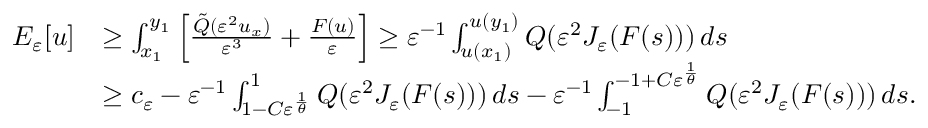<formula> <loc_0><loc_0><loc_500><loc_500>\begin{array} { r l } { E _ { \varepsilon } [ u ] } & { \geq \int _ { x _ { 1 } } ^ { y _ { 1 } } \left [ \frac { \tilde { Q } ( \varepsilon ^ { 2 } u _ { x } ) } { \varepsilon ^ { 3 } } + \frac { F ( u ) } { \varepsilon } \right ] \geq \varepsilon ^ { - 1 } \int _ { u ( x _ { 1 } ) } ^ { u ( y _ { 1 } ) } Q ( \varepsilon ^ { 2 } J _ { \varepsilon } ( F ( s ) ) ) \, d s } \\ & { \geq c _ { \varepsilon } - \varepsilon ^ { - 1 } \int _ { 1 - C \varepsilon ^ { \frac { 1 } \theta } } } ^ { 1 } Q ( \varepsilon ^ { 2 } J _ { \varepsilon } ( F ( s ) ) ) \, d s - \varepsilon ^ { - 1 } \int _ { - 1 } ^ { - 1 + C \varepsilon ^ { \frac { 1 } \theta } } } Q ( \varepsilon ^ { 2 } J _ { \varepsilon } ( F ( s ) ) ) \, d s . } \end{array}</formula> 